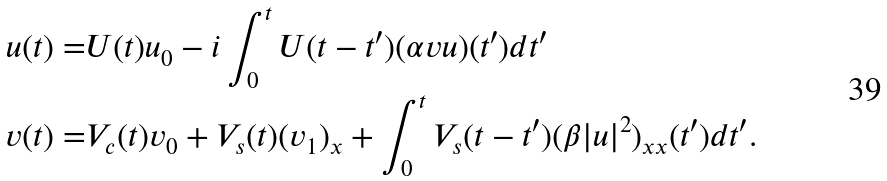<formula> <loc_0><loc_0><loc_500><loc_500>u ( t ) = & U ( t ) u _ { 0 } - i \int _ { 0 } ^ { t } U ( t - t ^ { \prime } ) ( \alpha v u ) ( t ^ { \prime } ) d t ^ { \prime } \\ v ( t ) = & V _ { c } ( t ) v _ { 0 } + V _ { s } ( t ) ( v _ { 1 } ) _ { x } + \int _ { 0 } ^ { t } V _ { s } ( t - t ^ { \prime } ) ( \beta | u | ^ { 2 } ) _ { x x } ( t ^ { \prime } ) d t ^ { \prime } .</formula> 